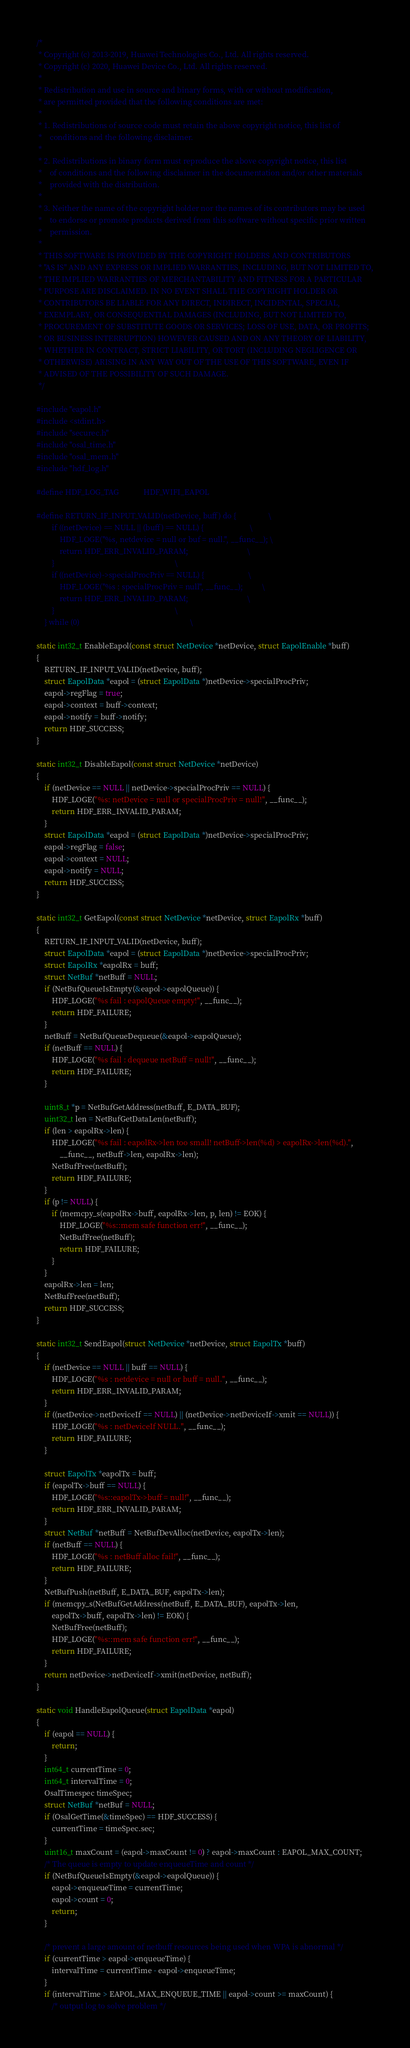Convert code to text. <code><loc_0><loc_0><loc_500><loc_500><_C_>/*
 * Copyright (c) 2013-2019, Huawei Technologies Co., Ltd. All rights reserved.
 * Copyright (c) 2020, Huawei Device Co., Ltd. All rights reserved.
 *
 * Redistribution and use in source and binary forms, with or without modification,
 * are permitted provided that the following conditions are met:
 *
 * 1. Redistributions of source code must retain the above copyright notice, this list of
 *    conditions and the following disclaimer.
 *
 * 2. Redistributions in binary form must reproduce the above copyright notice, this list
 *    of conditions and the following disclaimer in the documentation and/or other materials
 *    provided with the distribution.
 *
 * 3. Neither the name of the copyright holder nor the names of its contributors may be used
 *    to endorse or promote products derived from this software without specific prior written
 *    permission.
 *
 * THIS SOFTWARE IS PROVIDED BY THE COPYRIGHT HOLDERS AND CONTRIBUTORS
 * "AS IS" AND ANY EXPRESS OR IMPLIED WARRANTIES, INCLUDING, BUT NOT LIMITED TO,
 * THE IMPLIED WARRANTIES OF MERCHANTABILITY AND FITNESS FOR A PARTICULAR
 * PURPOSE ARE DISCLAIMED. IN NO EVENT SHALL THE COPYRIGHT HOLDER OR
 * CONTRIBUTORS BE LIABLE FOR ANY DIRECT, INDIRECT, INCIDENTAL, SPECIAL,
 * EXEMPLARY, OR CONSEQUENTIAL DAMAGES (INCLUDING, BUT NOT LIMITED TO,
 * PROCUREMENT OF SUBSTITUTE GOODS OR SERVICES; LOSS OF USE, DATA, OR PROFITS;
 * OR BUSINESS INTERRUPTION) HOWEVER CAUSED AND ON ANY THEORY OF LIABILITY,
 * WHETHER IN CONTRACT, STRICT LIABILITY, OR TORT (INCLUDING NEGLIGENCE OR
 * OTHERWISE) ARISING IN ANY WAY OUT OF THE USE OF THIS SOFTWARE, EVEN IF
 * ADVISED OF THE POSSIBILITY OF SUCH DAMAGE.
 */

#include "eapol.h"
#include <stdint.h>
#include "securec.h"
#include "osal_time.h"
#include "osal_mem.h"
#include "hdf_log.h"

#define HDF_LOG_TAG             HDF_WIFI_EAPOL

#define RETURN_IF_INPUT_VALID(netDevice, buff) do {                 \
        if ((netDevice) == NULL || (buff) == NULL) {                        \
            HDF_LOGE("%s, netdevice = null or buf = null.", __func__); \
            return HDF_ERR_INVALID_PARAM;                               \
        }                                                               \
        if ((netDevice)->specialProcPriv == NULL) {                       \
            HDF_LOGE("%s : specialProcPriv = null", __func__);          \
            return HDF_ERR_INVALID_PARAM;                               \
        }                                                               \
    } while (0)                                                          \

static int32_t EnableEapol(const struct NetDevice *netDevice, struct EapolEnable *buff)
{
    RETURN_IF_INPUT_VALID(netDevice, buff);
    struct EapolData *eapol = (struct EapolData *)netDevice->specialProcPriv;
    eapol->regFlag = true;
    eapol->context = buff->context;
    eapol->notify = buff->notify;
    return HDF_SUCCESS;
}

static int32_t DisableEapol(const struct NetDevice *netDevice)
{
    if (netDevice == NULL || netDevice->specialProcPriv == NULL) {
        HDF_LOGE("%s: netDevice = null or specialProcPriv = null!", __func__);
        return HDF_ERR_INVALID_PARAM;
    }
    struct EapolData *eapol = (struct EapolData *)netDevice->specialProcPriv;
    eapol->regFlag = false;
    eapol->context = NULL;
    eapol->notify = NULL;
    return HDF_SUCCESS;
}

static int32_t GetEapol(const struct NetDevice *netDevice, struct EapolRx *buff)
{
    RETURN_IF_INPUT_VALID(netDevice, buff);
    struct EapolData *eapol = (struct EapolData *)netDevice->specialProcPriv;
    struct EapolRx *eapolRx = buff;
    struct NetBuf *netBuff = NULL;
    if (NetBufQueueIsEmpty(&eapol->eapolQueue)) {
        HDF_LOGE("%s fail : eapolQueue empty!", __func__);
        return HDF_FAILURE;
    }
    netBuff = NetBufQueueDequeue(&eapol->eapolQueue);
    if (netBuff == NULL) {
        HDF_LOGE("%s fail : dequeue netBuff = null!", __func__);
        return HDF_FAILURE;
    }

    uint8_t *p = NetBufGetAddress(netBuff, E_DATA_BUF);
    uint32_t len = NetBufGetDataLen(netBuff);
    if (len > eapolRx->len) {
        HDF_LOGE("%s fail : eapolRx->len too small! netBuff->len(%d) > eapolRx->len(%d).",
            __func__, netBuff->len, eapolRx->len);
        NetBufFree(netBuff);
        return HDF_FAILURE;
    }
    if (p != NULL) {
        if (memcpy_s(eapolRx->buff, eapolRx->len, p, len) != EOK) {
            HDF_LOGE("%s::mem safe function err!", __func__);
            NetBufFree(netBuff);
            return HDF_FAILURE;
        }
    }
    eapolRx->len = len;
    NetBufFree(netBuff);
    return HDF_SUCCESS;
}

static int32_t SendEapol(struct NetDevice *netDevice, struct EapolTx *buff)
{
    if (netDevice == NULL || buff == NULL) {
        HDF_LOGE("%s : netdevice = null or buff = null.", __func__);
        return HDF_ERR_INVALID_PARAM;
    }
    if ((netDevice->netDeviceIf == NULL) || (netDevice->netDeviceIf->xmit == NULL)) {
        HDF_LOGE("%s : netDeviceIf NULL.", __func__);
        return HDF_FAILURE;
    }

    struct EapolTx *eapolTx = buff;
    if (eapolTx->buff == NULL) {
        HDF_LOGE("%s::eapolTx->buff = null!", __func__);
        return HDF_ERR_INVALID_PARAM;
    }
    struct NetBuf *netBuff = NetBufDevAlloc(netDevice, eapolTx->len);
    if (netBuff == NULL) {
        HDF_LOGE("%s : netBuff alloc fail!", __func__);
        return HDF_FAILURE;
    }
    NetBufPush(netBuff, E_DATA_BUF, eapolTx->len);
    if (memcpy_s(NetBufGetAddress(netBuff, E_DATA_BUF), eapolTx->len,
        eapolTx->buff, eapolTx->len) != EOK) {
        NetBufFree(netBuff);
        HDF_LOGE("%s::mem safe function err!", __func__);
        return HDF_FAILURE;
    }
    return netDevice->netDeviceIf->xmit(netDevice, netBuff);
}

static void HandleEapolQueue(struct EapolData *eapol)
{
    if (eapol == NULL) {
        return;
    }
    int64_t currentTime = 0;
    int64_t intervalTime = 0;
    OsalTimespec timeSpec;
    struct NetBuf *netBuf = NULL;
    if (OsalGetTime(&timeSpec) == HDF_SUCCESS) {
        currentTime = timeSpec.sec;
    }
    uint16_t maxCount = (eapol->maxCount != 0) ? eapol->maxCount : EAPOL_MAX_COUNT;
    /* The queue is empty to update enqueueTime and count */
    if (NetBufQueueIsEmpty(&eapol->eapolQueue)) {
        eapol->enqueueTime = currentTime;
        eapol->count = 0;
        return;
    }

    /* prevent a large amount of netbuff resources being used when WPA is abnormal */
    if (currentTime > eapol->enqueueTime) {
        intervalTime = currentTime - eapol->enqueueTime;
    }
    if (intervalTime > EAPOL_MAX_ENQUEUE_TIME || eapol->count >= maxCount) {
        /* output log to solve problem */</code> 